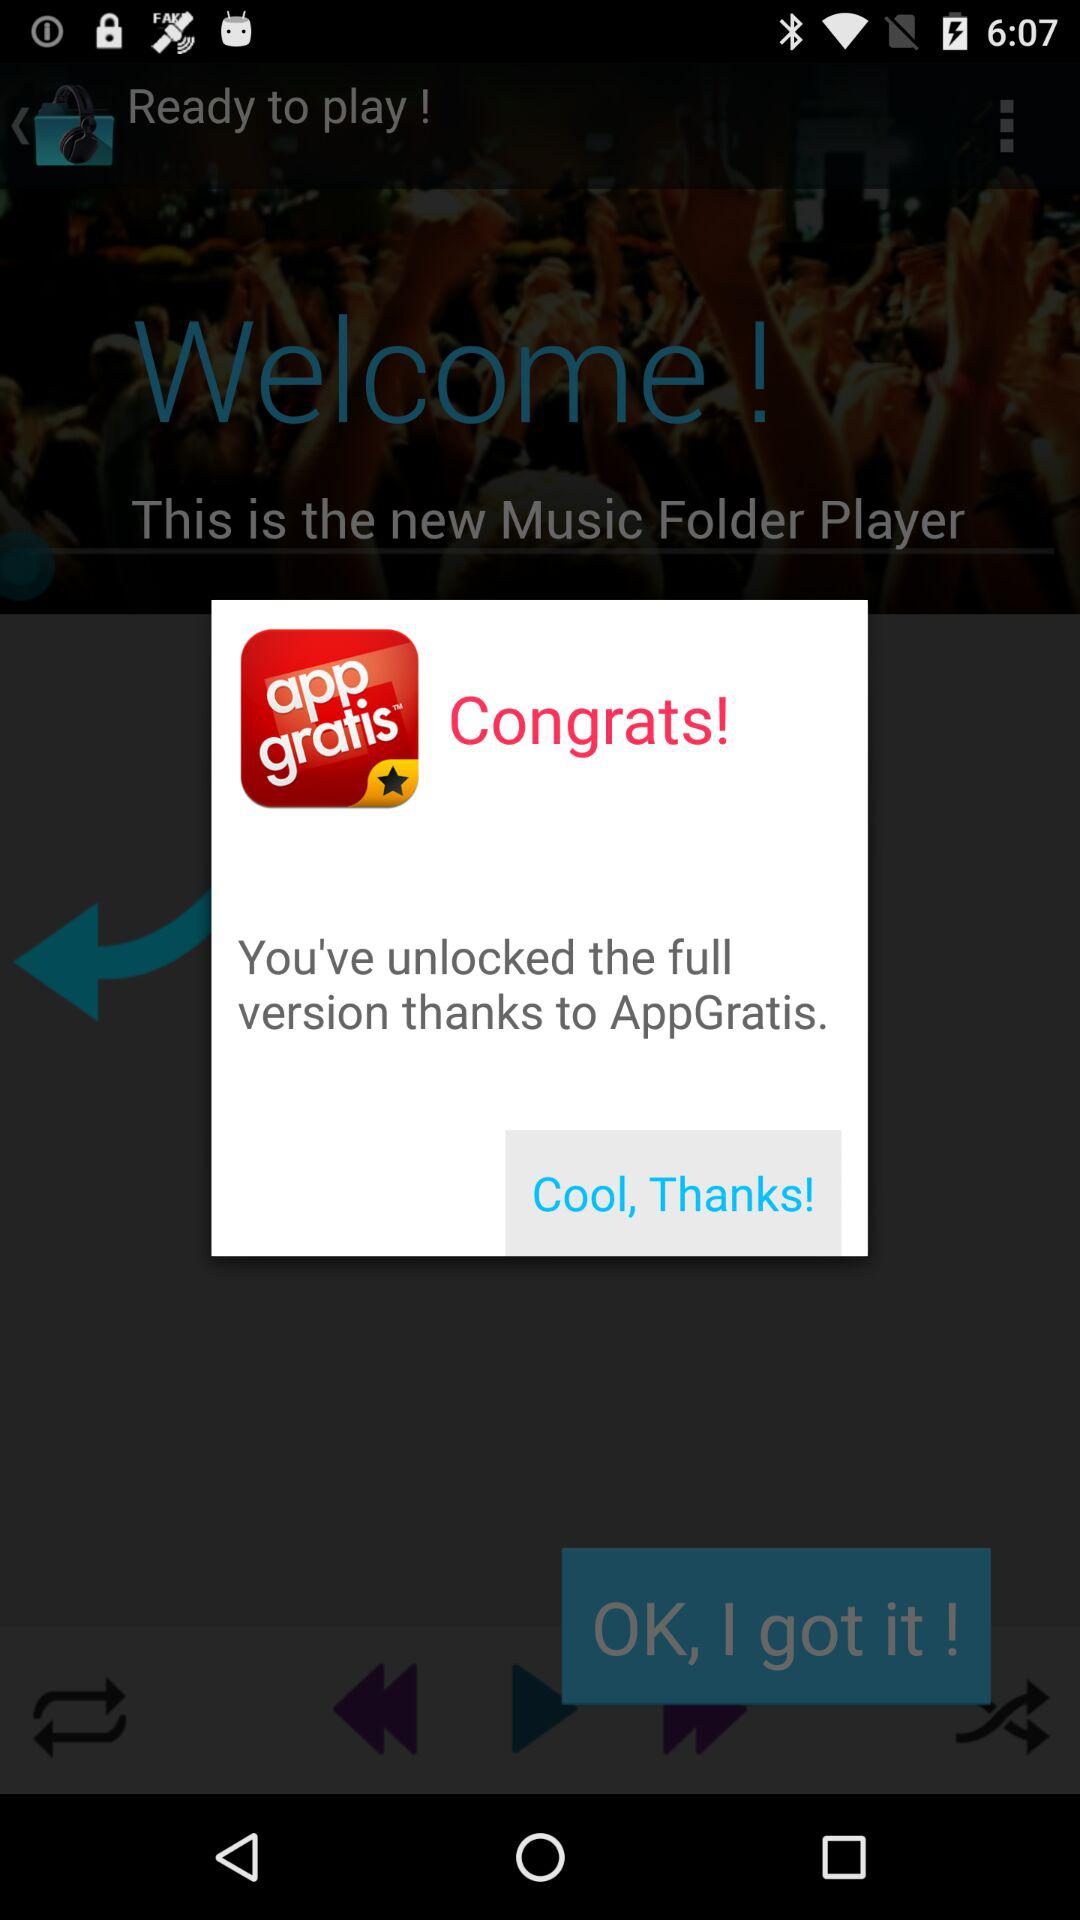What is the application name? The application name is "AppGratis". 